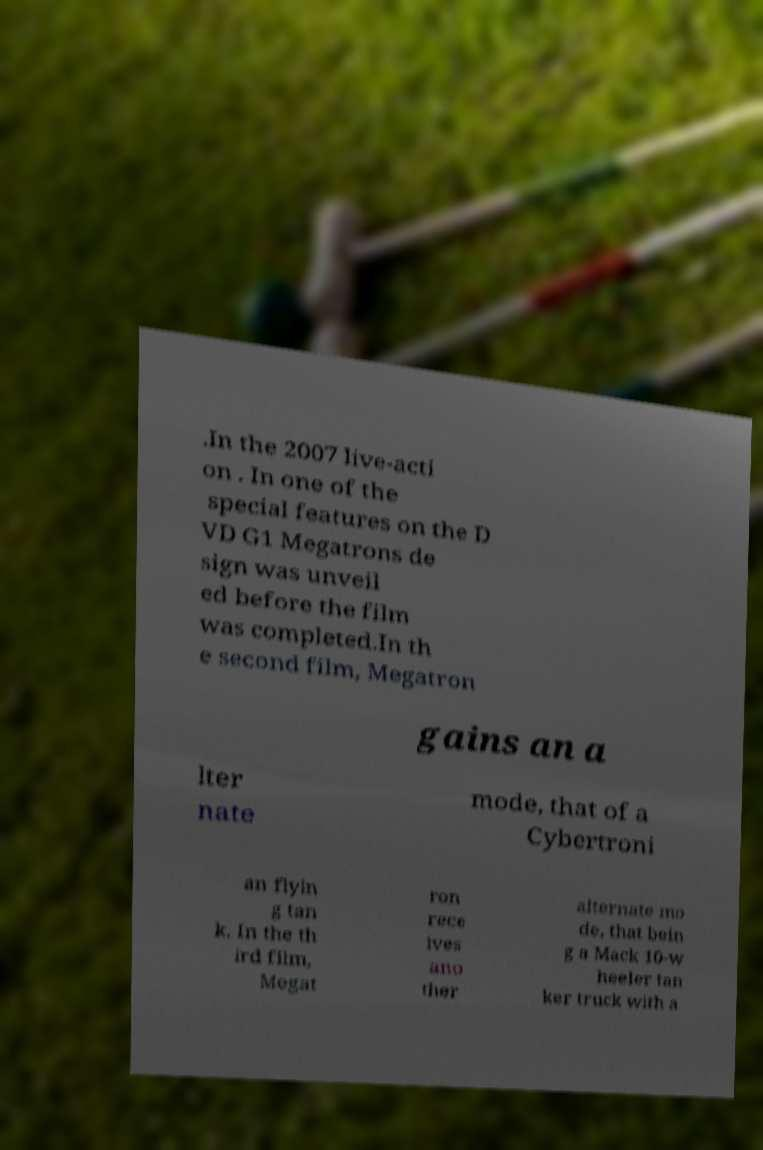Can you accurately transcribe the text from the provided image for me? .In the 2007 live-acti on . In one of the special features on the D VD G1 Megatrons de sign was unveil ed before the film was completed.In th e second film, Megatron gains an a lter nate mode, that of a Cybertroni an flyin g tan k. In the th ird film, Megat ron rece ives ano ther alternate mo de, that bein g a Mack 10-w heeler tan ker truck with a 